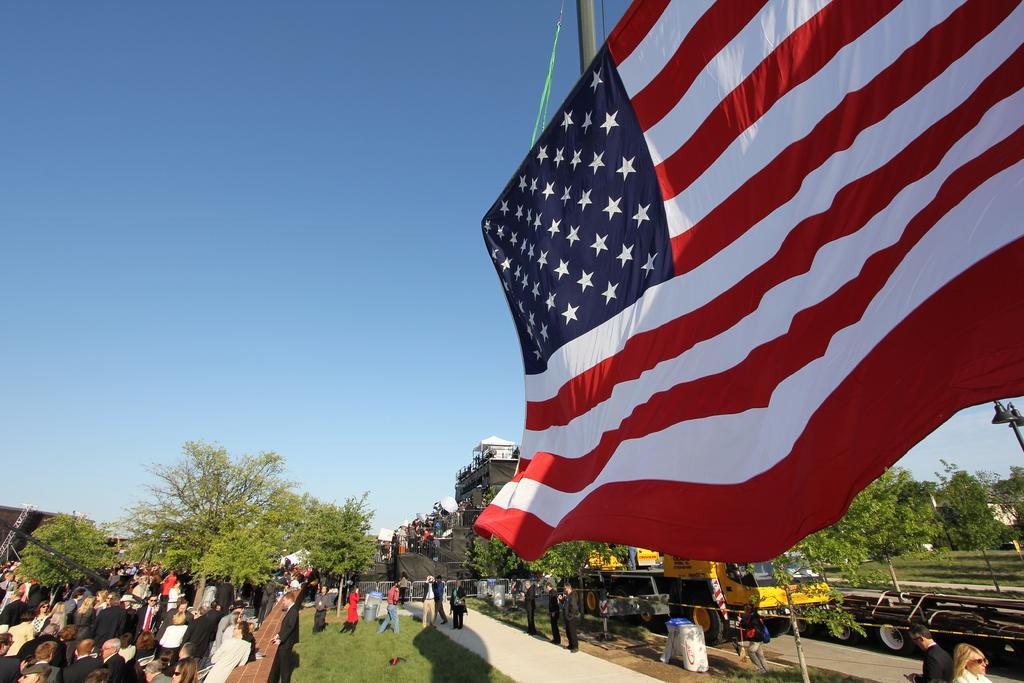Could you give a brief overview of what you see in this image? At the bottom I can see a crowd and vehicles on the ground. In the background I can see trees, buildings and a flag. At the top I can see the sky. This image is taken during a day. 